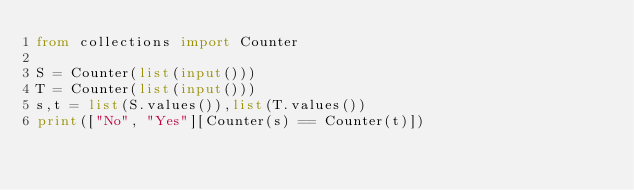Convert code to text. <code><loc_0><loc_0><loc_500><loc_500><_Python_>from collections import Counter

S = Counter(list(input()))
T = Counter(list(input()))
s,t = list(S.values()),list(T.values())
print(["No", "Yes"][Counter(s) == Counter(t)])
</code> 